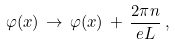<formula> <loc_0><loc_0><loc_500><loc_500>\varphi ( x ) \, \to \, \varphi ( x ) \, + \, \frac { 2 \pi n } { e L } \, ,</formula> 